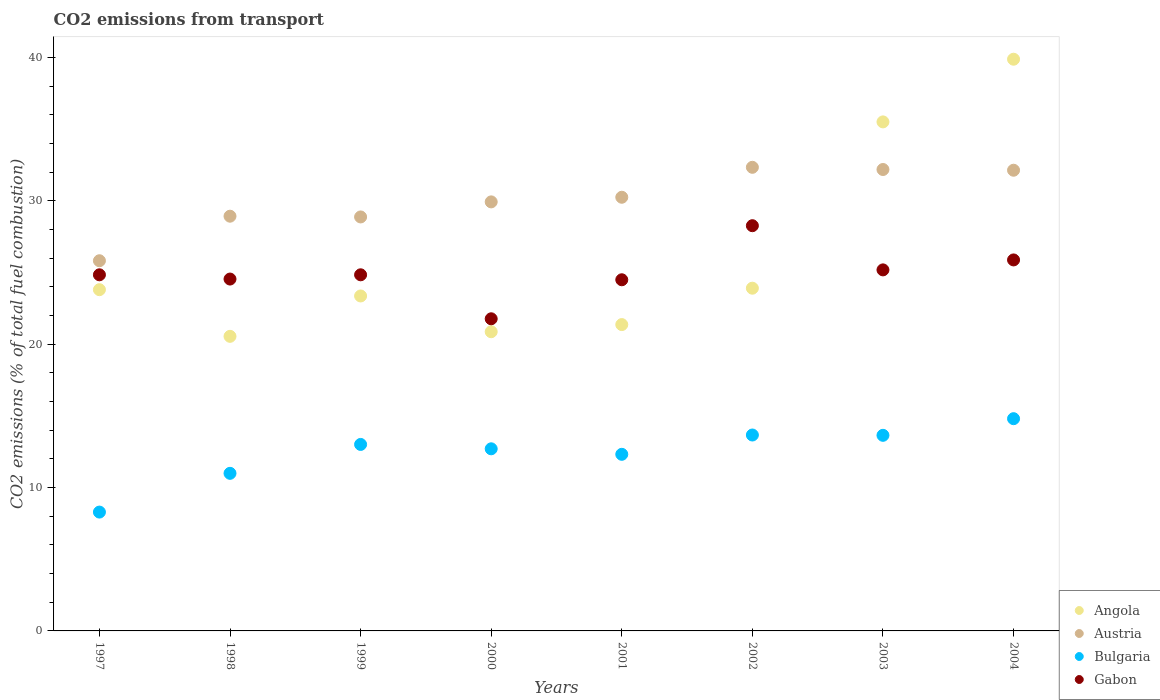Is the number of dotlines equal to the number of legend labels?
Your answer should be very brief. Yes. What is the total CO2 emitted in Gabon in 2002?
Keep it short and to the point. 28.26. Across all years, what is the maximum total CO2 emitted in Gabon?
Offer a terse response. 28.26. Across all years, what is the minimum total CO2 emitted in Gabon?
Your answer should be very brief. 21.77. In which year was the total CO2 emitted in Austria maximum?
Make the answer very short. 2002. What is the total total CO2 emitted in Gabon in the graph?
Offer a very short reply. 199.79. What is the difference between the total CO2 emitted in Bulgaria in 2003 and that in 2004?
Keep it short and to the point. -1.16. What is the difference between the total CO2 emitted in Austria in 2002 and the total CO2 emitted in Bulgaria in 1997?
Give a very brief answer. 24.05. What is the average total CO2 emitted in Bulgaria per year?
Offer a terse response. 12.43. In the year 2001, what is the difference between the total CO2 emitted in Austria and total CO2 emitted in Bulgaria?
Provide a short and direct response. 17.93. In how many years, is the total CO2 emitted in Bulgaria greater than 24?
Keep it short and to the point. 0. What is the ratio of the total CO2 emitted in Austria in 2002 to that in 2003?
Keep it short and to the point. 1. Is the total CO2 emitted in Bulgaria in 1997 less than that in 2000?
Ensure brevity in your answer.  Yes. What is the difference between the highest and the second highest total CO2 emitted in Bulgaria?
Your response must be concise. 1.14. What is the difference between the highest and the lowest total CO2 emitted in Angola?
Provide a short and direct response. 19.33. In how many years, is the total CO2 emitted in Bulgaria greater than the average total CO2 emitted in Bulgaria taken over all years?
Offer a very short reply. 5. Is it the case that in every year, the sum of the total CO2 emitted in Austria and total CO2 emitted in Bulgaria  is greater than the sum of total CO2 emitted in Angola and total CO2 emitted in Gabon?
Provide a short and direct response. Yes. Is the total CO2 emitted in Angola strictly less than the total CO2 emitted in Gabon over the years?
Your response must be concise. No. Are the values on the major ticks of Y-axis written in scientific E-notation?
Offer a terse response. No. Does the graph contain any zero values?
Your answer should be very brief. No. Where does the legend appear in the graph?
Your answer should be very brief. Bottom right. How many legend labels are there?
Keep it short and to the point. 4. How are the legend labels stacked?
Provide a succinct answer. Vertical. What is the title of the graph?
Keep it short and to the point. CO2 emissions from transport. What is the label or title of the X-axis?
Your answer should be very brief. Years. What is the label or title of the Y-axis?
Offer a very short reply. CO2 emissions (% of total fuel combustion). What is the CO2 emissions (% of total fuel combustion) of Angola in 1997?
Make the answer very short. 23.8. What is the CO2 emissions (% of total fuel combustion) in Austria in 1997?
Keep it short and to the point. 25.82. What is the CO2 emissions (% of total fuel combustion) of Bulgaria in 1997?
Give a very brief answer. 8.29. What is the CO2 emissions (% of total fuel combustion) in Gabon in 1997?
Keep it short and to the point. 24.84. What is the CO2 emissions (% of total fuel combustion) of Angola in 1998?
Provide a succinct answer. 20.54. What is the CO2 emissions (% of total fuel combustion) in Austria in 1998?
Offer a terse response. 28.92. What is the CO2 emissions (% of total fuel combustion) of Bulgaria in 1998?
Offer a very short reply. 10.99. What is the CO2 emissions (% of total fuel combustion) in Gabon in 1998?
Offer a terse response. 24.54. What is the CO2 emissions (% of total fuel combustion) in Angola in 1999?
Give a very brief answer. 23.36. What is the CO2 emissions (% of total fuel combustion) in Austria in 1999?
Provide a succinct answer. 28.87. What is the CO2 emissions (% of total fuel combustion) in Bulgaria in 1999?
Your answer should be compact. 13.01. What is the CO2 emissions (% of total fuel combustion) in Gabon in 1999?
Your response must be concise. 24.84. What is the CO2 emissions (% of total fuel combustion) in Angola in 2000?
Keep it short and to the point. 20.87. What is the CO2 emissions (% of total fuel combustion) of Austria in 2000?
Provide a succinct answer. 29.92. What is the CO2 emissions (% of total fuel combustion) of Bulgaria in 2000?
Offer a terse response. 12.7. What is the CO2 emissions (% of total fuel combustion) in Gabon in 2000?
Your answer should be compact. 21.77. What is the CO2 emissions (% of total fuel combustion) in Angola in 2001?
Your answer should be compact. 21.36. What is the CO2 emissions (% of total fuel combustion) of Austria in 2001?
Offer a terse response. 30.24. What is the CO2 emissions (% of total fuel combustion) of Bulgaria in 2001?
Provide a succinct answer. 12.32. What is the CO2 emissions (% of total fuel combustion) in Gabon in 2001?
Offer a terse response. 24.49. What is the CO2 emissions (% of total fuel combustion) of Angola in 2002?
Your response must be concise. 23.9. What is the CO2 emissions (% of total fuel combustion) in Austria in 2002?
Offer a very short reply. 32.33. What is the CO2 emissions (% of total fuel combustion) of Bulgaria in 2002?
Give a very brief answer. 13.66. What is the CO2 emissions (% of total fuel combustion) in Gabon in 2002?
Make the answer very short. 28.26. What is the CO2 emissions (% of total fuel combustion) of Angola in 2003?
Provide a succinct answer. 35.5. What is the CO2 emissions (% of total fuel combustion) of Austria in 2003?
Offer a very short reply. 32.18. What is the CO2 emissions (% of total fuel combustion) in Bulgaria in 2003?
Offer a very short reply. 13.64. What is the CO2 emissions (% of total fuel combustion) in Gabon in 2003?
Offer a very short reply. 25.18. What is the CO2 emissions (% of total fuel combustion) of Angola in 2004?
Keep it short and to the point. 39.87. What is the CO2 emissions (% of total fuel combustion) in Austria in 2004?
Provide a succinct answer. 32.13. What is the CO2 emissions (% of total fuel combustion) in Bulgaria in 2004?
Your answer should be very brief. 14.8. What is the CO2 emissions (% of total fuel combustion) of Gabon in 2004?
Keep it short and to the point. 25.87. Across all years, what is the maximum CO2 emissions (% of total fuel combustion) of Angola?
Keep it short and to the point. 39.87. Across all years, what is the maximum CO2 emissions (% of total fuel combustion) in Austria?
Offer a terse response. 32.33. Across all years, what is the maximum CO2 emissions (% of total fuel combustion) of Bulgaria?
Your answer should be compact. 14.8. Across all years, what is the maximum CO2 emissions (% of total fuel combustion) of Gabon?
Your answer should be very brief. 28.26. Across all years, what is the minimum CO2 emissions (% of total fuel combustion) in Angola?
Offer a terse response. 20.54. Across all years, what is the minimum CO2 emissions (% of total fuel combustion) in Austria?
Your answer should be very brief. 25.82. Across all years, what is the minimum CO2 emissions (% of total fuel combustion) of Bulgaria?
Provide a succinct answer. 8.29. Across all years, what is the minimum CO2 emissions (% of total fuel combustion) of Gabon?
Provide a succinct answer. 21.77. What is the total CO2 emissions (% of total fuel combustion) in Angola in the graph?
Your response must be concise. 209.21. What is the total CO2 emissions (% of total fuel combustion) in Austria in the graph?
Offer a very short reply. 240.42. What is the total CO2 emissions (% of total fuel combustion) of Bulgaria in the graph?
Keep it short and to the point. 99.41. What is the total CO2 emissions (% of total fuel combustion) in Gabon in the graph?
Offer a terse response. 199.79. What is the difference between the CO2 emissions (% of total fuel combustion) of Angola in 1997 and that in 1998?
Your answer should be compact. 3.25. What is the difference between the CO2 emissions (% of total fuel combustion) of Austria in 1997 and that in 1998?
Offer a very short reply. -3.11. What is the difference between the CO2 emissions (% of total fuel combustion) in Bulgaria in 1997 and that in 1998?
Your answer should be very brief. -2.7. What is the difference between the CO2 emissions (% of total fuel combustion) in Gabon in 1997 and that in 1998?
Your response must be concise. 0.3. What is the difference between the CO2 emissions (% of total fuel combustion) of Angola in 1997 and that in 1999?
Offer a terse response. 0.44. What is the difference between the CO2 emissions (% of total fuel combustion) in Austria in 1997 and that in 1999?
Ensure brevity in your answer.  -3.05. What is the difference between the CO2 emissions (% of total fuel combustion) of Bulgaria in 1997 and that in 1999?
Ensure brevity in your answer.  -4.72. What is the difference between the CO2 emissions (% of total fuel combustion) in Angola in 1997 and that in 2000?
Provide a succinct answer. 2.93. What is the difference between the CO2 emissions (% of total fuel combustion) in Austria in 1997 and that in 2000?
Offer a very short reply. -4.1. What is the difference between the CO2 emissions (% of total fuel combustion) in Bulgaria in 1997 and that in 2000?
Offer a terse response. -4.41. What is the difference between the CO2 emissions (% of total fuel combustion) in Gabon in 1997 and that in 2000?
Ensure brevity in your answer.  3.07. What is the difference between the CO2 emissions (% of total fuel combustion) of Angola in 1997 and that in 2001?
Offer a very short reply. 2.43. What is the difference between the CO2 emissions (% of total fuel combustion) of Austria in 1997 and that in 2001?
Your response must be concise. -4.43. What is the difference between the CO2 emissions (% of total fuel combustion) in Bulgaria in 1997 and that in 2001?
Ensure brevity in your answer.  -4.03. What is the difference between the CO2 emissions (% of total fuel combustion) in Gabon in 1997 and that in 2001?
Give a very brief answer. 0.35. What is the difference between the CO2 emissions (% of total fuel combustion) in Angola in 1997 and that in 2002?
Provide a short and direct response. -0.1. What is the difference between the CO2 emissions (% of total fuel combustion) of Austria in 1997 and that in 2002?
Keep it short and to the point. -6.52. What is the difference between the CO2 emissions (% of total fuel combustion) in Bulgaria in 1997 and that in 2002?
Provide a succinct answer. -5.38. What is the difference between the CO2 emissions (% of total fuel combustion) of Gabon in 1997 and that in 2002?
Your answer should be compact. -3.42. What is the difference between the CO2 emissions (% of total fuel combustion) of Angola in 1997 and that in 2003?
Your response must be concise. -11.7. What is the difference between the CO2 emissions (% of total fuel combustion) in Austria in 1997 and that in 2003?
Your answer should be compact. -6.36. What is the difference between the CO2 emissions (% of total fuel combustion) in Bulgaria in 1997 and that in 2003?
Ensure brevity in your answer.  -5.35. What is the difference between the CO2 emissions (% of total fuel combustion) of Gabon in 1997 and that in 2003?
Provide a short and direct response. -0.34. What is the difference between the CO2 emissions (% of total fuel combustion) of Angola in 1997 and that in 2004?
Provide a succinct answer. -16.07. What is the difference between the CO2 emissions (% of total fuel combustion) in Austria in 1997 and that in 2004?
Your answer should be compact. -6.31. What is the difference between the CO2 emissions (% of total fuel combustion) of Bulgaria in 1997 and that in 2004?
Provide a succinct answer. -6.51. What is the difference between the CO2 emissions (% of total fuel combustion) of Gabon in 1997 and that in 2004?
Your answer should be very brief. -1.04. What is the difference between the CO2 emissions (% of total fuel combustion) in Angola in 1998 and that in 1999?
Give a very brief answer. -2.82. What is the difference between the CO2 emissions (% of total fuel combustion) in Austria in 1998 and that in 1999?
Ensure brevity in your answer.  0.05. What is the difference between the CO2 emissions (% of total fuel combustion) of Bulgaria in 1998 and that in 1999?
Provide a short and direct response. -2.02. What is the difference between the CO2 emissions (% of total fuel combustion) in Gabon in 1998 and that in 1999?
Make the answer very short. -0.3. What is the difference between the CO2 emissions (% of total fuel combustion) of Angola in 1998 and that in 2000?
Make the answer very short. -0.32. What is the difference between the CO2 emissions (% of total fuel combustion) in Austria in 1998 and that in 2000?
Your answer should be compact. -1. What is the difference between the CO2 emissions (% of total fuel combustion) in Bulgaria in 1998 and that in 2000?
Make the answer very short. -1.71. What is the difference between the CO2 emissions (% of total fuel combustion) of Gabon in 1998 and that in 2000?
Give a very brief answer. 2.77. What is the difference between the CO2 emissions (% of total fuel combustion) of Angola in 1998 and that in 2001?
Offer a terse response. -0.82. What is the difference between the CO2 emissions (% of total fuel combustion) of Austria in 1998 and that in 2001?
Provide a short and direct response. -1.32. What is the difference between the CO2 emissions (% of total fuel combustion) of Bulgaria in 1998 and that in 2001?
Offer a terse response. -1.33. What is the difference between the CO2 emissions (% of total fuel combustion) in Gabon in 1998 and that in 2001?
Offer a terse response. 0.05. What is the difference between the CO2 emissions (% of total fuel combustion) in Angola in 1998 and that in 2002?
Ensure brevity in your answer.  -3.36. What is the difference between the CO2 emissions (% of total fuel combustion) of Austria in 1998 and that in 2002?
Keep it short and to the point. -3.41. What is the difference between the CO2 emissions (% of total fuel combustion) of Bulgaria in 1998 and that in 2002?
Offer a very short reply. -2.67. What is the difference between the CO2 emissions (% of total fuel combustion) of Gabon in 1998 and that in 2002?
Provide a short and direct response. -3.72. What is the difference between the CO2 emissions (% of total fuel combustion) of Angola in 1998 and that in 2003?
Your answer should be compact. -14.96. What is the difference between the CO2 emissions (% of total fuel combustion) of Austria in 1998 and that in 2003?
Provide a short and direct response. -3.26. What is the difference between the CO2 emissions (% of total fuel combustion) of Bulgaria in 1998 and that in 2003?
Ensure brevity in your answer.  -2.65. What is the difference between the CO2 emissions (% of total fuel combustion) in Gabon in 1998 and that in 2003?
Ensure brevity in your answer.  -0.64. What is the difference between the CO2 emissions (% of total fuel combustion) of Angola in 1998 and that in 2004?
Make the answer very short. -19.33. What is the difference between the CO2 emissions (% of total fuel combustion) of Austria in 1998 and that in 2004?
Give a very brief answer. -3.21. What is the difference between the CO2 emissions (% of total fuel combustion) of Bulgaria in 1998 and that in 2004?
Your answer should be very brief. -3.81. What is the difference between the CO2 emissions (% of total fuel combustion) in Gabon in 1998 and that in 2004?
Keep it short and to the point. -1.33. What is the difference between the CO2 emissions (% of total fuel combustion) of Angola in 1999 and that in 2000?
Your response must be concise. 2.49. What is the difference between the CO2 emissions (% of total fuel combustion) in Austria in 1999 and that in 2000?
Ensure brevity in your answer.  -1.05. What is the difference between the CO2 emissions (% of total fuel combustion) in Bulgaria in 1999 and that in 2000?
Offer a very short reply. 0.31. What is the difference between the CO2 emissions (% of total fuel combustion) in Gabon in 1999 and that in 2000?
Offer a very short reply. 3.07. What is the difference between the CO2 emissions (% of total fuel combustion) of Angola in 1999 and that in 2001?
Keep it short and to the point. 2. What is the difference between the CO2 emissions (% of total fuel combustion) of Austria in 1999 and that in 2001?
Provide a short and direct response. -1.37. What is the difference between the CO2 emissions (% of total fuel combustion) in Bulgaria in 1999 and that in 2001?
Provide a short and direct response. 0.69. What is the difference between the CO2 emissions (% of total fuel combustion) in Gabon in 1999 and that in 2001?
Your answer should be compact. 0.35. What is the difference between the CO2 emissions (% of total fuel combustion) of Angola in 1999 and that in 2002?
Offer a very short reply. -0.54. What is the difference between the CO2 emissions (% of total fuel combustion) in Austria in 1999 and that in 2002?
Offer a very short reply. -3.46. What is the difference between the CO2 emissions (% of total fuel combustion) in Bulgaria in 1999 and that in 2002?
Your answer should be very brief. -0.66. What is the difference between the CO2 emissions (% of total fuel combustion) in Gabon in 1999 and that in 2002?
Your answer should be compact. -3.42. What is the difference between the CO2 emissions (% of total fuel combustion) in Angola in 1999 and that in 2003?
Provide a succinct answer. -12.14. What is the difference between the CO2 emissions (% of total fuel combustion) of Austria in 1999 and that in 2003?
Provide a succinct answer. -3.31. What is the difference between the CO2 emissions (% of total fuel combustion) in Bulgaria in 1999 and that in 2003?
Offer a terse response. -0.64. What is the difference between the CO2 emissions (% of total fuel combustion) of Gabon in 1999 and that in 2003?
Your answer should be very brief. -0.34. What is the difference between the CO2 emissions (% of total fuel combustion) in Angola in 1999 and that in 2004?
Provide a succinct answer. -16.51. What is the difference between the CO2 emissions (% of total fuel combustion) of Austria in 1999 and that in 2004?
Your answer should be very brief. -3.26. What is the difference between the CO2 emissions (% of total fuel combustion) of Bulgaria in 1999 and that in 2004?
Provide a short and direct response. -1.8. What is the difference between the CO2 emissions (% of total fuel combustion) of Gabon in 1999 and that in 2004?
Ensure brevity in your answer.  -1.04. What is the difference between the CO2 emissions (% of total fuel combustion) in Angola in 2000 and that in 2001?
Provide a short and direct response. -0.5. What is the difference between the CO2 emissions (% of total fuel combustion) in Austria in 2000 and that in 2001?
Keep it short and to the point. -0.32. What is the difference between the CO2 emissions (% of total fuel combustion) in Bulgaria in 2000 and that in 2001?
Ensure brevity in your answer.  0.38. What is the difference between the CO2 emissions (% of total fuel combustion) in Gabon in 2000 and that in 2001?
Ensure brevity in your answer.  -2.72. What is the difference between the CO2 emissions (% of total fuel combustion) of Angola in 2000 and that in 2002?
Keep it short and to the point. -3.04. What is the difference between the CO2 emissions (% of total fuel combustion) in Austria in 2000 and that in 2002?
Offer a very short reply. -2.41. What is the difference between the CO2 emissions (% of total fuel combustion) in Bulgaria in 2000 and that in 2002?
Provide a succinct answer. -0.96. What is the difference between the CO2 emissions (% of total fuel combustion) in Gabon in 2000 and that in 2002?
Your answer should be compact. -6.49. What is the difference between the CO2 emissions (% of total fuel combustion) of Angola in 2000 and that in 2003?
Your answer should be compact. -14.63. What is the difference between the CO2 emissions (% of total fuel combustion) of Austria in 2000 and that in 2003?
Your response must be concise. -2.26. What is the difference between the CO2 emissions (% of total fuel combustion) of Bulgaria in 2000 and that in 2003?
Keep it short and to the point. -0.94. What is the difference between the CO2 emissions (% of total fuel combustion) of Gabon in 2000 and that in 2003?
Give a very brief answer. -3.41. What is the difference between the CO2 emissions (% of total fuel combustion) in Angola in 2000 and that in 2004?
Your response must be concise. -19.01. What is the difference between the CO2 emissions (% of total fuel combustion) in Austria in 2000 and that in 2004?
Your answer should be very brief. -2.21. What is the difference between the CO2 emissions (% of total fuel combustion) of Bulgaria in 2000 and that in 2004?
Offer a very short reply. -2.1. What is the difference between the CO2 emissions (% of total fuel combustion) in Gabon in 2000 and that in 2004?
Give a very brief answer. -4.11. What is the difference between the CO2 emissions (% of total fuel combustion) of Angola in 2001 and that in 2002?
Offer a terse response. -2.54. What is the difference between the CO2 emissions (% of total fuel combustion) of Austria in 2001 and that in 2002?
Provide a short and direct response. -2.09. What is the difference between the CO2 emissions (% of total fuel combustion) of Bulgaria in 2001 and that in 2002?
Provide a short and direct response. -1.35. What is the difference between the CO2 emissions (% of total fuel combustion) in Gabon in 2001 and that in 2002?
Your answer should be very brief. -3.77. What is the difference between the CO2 emissions (% of total fuel combustion) of Angola in 2001 and that in 2003?
Your answer should be very brief. -14.14. What is the difference between the CO2 emissions (% of total fuel combustion) in Austria in 2001 and that in 2003?
Your answer should be compact. -1.94. What is the difference between the CO2 emissions (% of total fuel combustion) in Bulgaria in 2001 and that in 2003?
Ensure brevity in your answer.  -1.32. What is the difference between the CO2 emissions (% of total fuel combustion) in Gabon in 2001 and that in 2003?
Your answer should be compact. -0.69. What is the difference between the CO2 emissions (% of total fuel combustion) of Angola in 2001 and that in 2004?
Keep it short and to the point. -18.51. What is the difference between the CO2 emissions (% of total fuel combustion) in Austria in 2001 and that in 2004?
Ensure brevity in your answer.  -1.89. What is the difference between the CO2 emissions (% of total fuel combustion) in Bulgaria in 2001 and that in 2004?
Your answer should be very brief. -2.48. What is the difference between the CO2 emissions (% of total fuel combustion) of Gabon in 2001 and that in 2004?
Your answer should be very brief. -1.38. What is the difference between the CO2 emissions (% of total fuel combustion) in Angola in 2002 and that in 2003?
Your answer should be very brief. -11.6. What is the difference between the CO2 emissions (% of total fuel combustion) of Austria in 2002 and that in 2003?
Provide a short and direct response. 0.15. What is the difference between the CO2 emissions (% of total fuel combustion) in Bulgaria in 2002 and that in 2003?
Give a very brief answer. 0.02. What is the difference between the CO2 emissions (% of total fuel combustion) of Gabon in 2002 and that in 2003?
Give a very brief answer. 3.08. What is the difference between the CO2 emissions (% of total fuel combustion) in Angola in 2002 and that in 2004?
Offer a terse response. -15.97. What is the difference between the CO2 emissions (% of total fuel combustion) in Austria in 2002 and that in 2004?
Provide a succinct answer. 0.2. What is the difference between the CO2 emissions (% of total fuel combustion) of Bulgaria in 2002 and that in 2004?
Provide a succinct answer. -1.14. What is the difference between the CO2 emissions (% of total fuel combustion) of Gabon in 2002 and that in 2004?
Ensure brevity in your answer.  2.39. What is the difference between the CO2 emissions (% of total fuel combustion) of Angola in 2003 and that in 2004?
Give a very brief answer. -4.37. What is the difference between the CO2 emissions (% of total fuel combustion) in Austria in 2003 and that in 2004?
Your answer should be very brief. 0.05. What is the difference between the CO2 emissions (% of total fuel combustion) in Bulgaria in 2003 and that in 2004?
Give a very brief answer. -1.16. What is the difference between the CO2 emissions (% of total fuel combustion) of Gabon in 2003 and that in 2004?
Provide a short and direct response. -0.69. What is the difference between the CO2 emissions (% of total fuel combustion) of Angola in 1997 and the CO2 emissions (% of total fuel combustion) of Austria in 1998?
Give a very brief answer. -5.12. What is the difference between the CO2 emissions (% of total fuel combustion) of Angola in 1997 and the CO2 emissions (% of total fuel combustion) of Bulgaria in 1998?
Your answer should be very brief. 12.81. What is the difference between the CO2 emissions (% of total fuel combustion) in Angola in 1997 and the CO2 emissions (% of total fuel combustion) in Gabon in 1998?
Your answer should be compact. -0.74. What is the difference between the CO2 emissions (% of total fuel combustion) of Austria in 1997 and the CO2 emissions (% of total fuel combustion) of Bulgaria in 1998?
Provide a succinct answer. 14.83. What is the difference between the CO2 emissions (% of total fuel combustion) in Austria in 1997 and the CO2 emissions (% of total fuel combustion) in Gabon in 1998?
Provide a succinct answer. 1.28. What is the difference between the CO2 emissions (% of total fuel combustion) of Bulgaria in 1997 and the CO2 emissions (% of total fuel combustion) of Gabon in 1998?
Keep it short and to the point. -16.25. What is the difference between the CO2 emissions (% of total fuel combustion) in Angola in 1997 and the CO2 emissions (% of total fuel combustion) in Austria in 1999?
Your answer should be very brief. -5.07. What is the difference between the CO2 emissions (% of total fuel combustion) of Angola in 1997 and the CO2 emissions (% of total fuel combustion) of Bulgaria in 1999?
Make the answer very short. 10.79. What is the difference between the CO2 emissions (% of total fuel combustion) in Angola in 1997 and the CO2 emissions (% of total fuel combustion) in Gabon in 1999?
Your answer should be very brief. -1.04. What is the difference between the CO2 emissions (% of total fuel combustion) of Austria in 1997 and the CO2 emissions (% of total fuel combustion) of Bulgaria in 1999?
Give a very brief answer. 12.81. What is the difference between the CO2 emissions (% of total fuel combustion) of Austria in 1997 and the CO2 emissions (% of total fuel combustion) of Gabon in 1999?
Your response must be concise. 0.98. What is the difference between the CO2 emissions (% of total fuel combustion) in Bulgaria in 1997 and the CO2 emissions (% of total fuel combustion) in Gabon in 1999?
Your response must be concise. -16.55. What is the difference between the CO2 emissions (% of total fuel combustion) of Angola in 1997 and the CO2 emissions (% of total fuel combustion) of Austria in 2000?
Your answer should be compact. -6.12. What is the difference between the CO2 emissions (% of total fuel combustion) in Angola in 1997 and the CO2 emissions (% of total fuel combustion) in Bulgaria in 2000?
Provide a succinct answer. 11.1. What is the difference between the CO2 emissions (% of total fuel combustion) of Angola in 1997 and the CO2 emissions (% of total fuel combustion) of Gabon in 2000?
Provide a succinct answer. 2.03. What is the difference between the CO2 emissions (% of total fuel combustion) of Austria in 1997 and the CO2 emissions (% of total fuel combustion) of Bulgaria in 2000?
Give a very brief answer. 13.12. What is the difference between the CO2 emissions (% of total fuel combustion) of Austria in 1997 and the CO2 emissions (% of total fuel combustion) of Gabon in 2000?
Provide a succinct answer. 4.05. What is the difference between the CO2 emissions (% of total fuel combustion) of Bulgaria in 1997 and the CO2 emissions (% of total fuel combustion) of Gabon in 2000?
Your response must be concise. -13.48. What is the difference between the CO2 emissions (% of total fuel combustion) in Angola in 1997 and the CO2 emissions (% of total fuel combustion) in Austria in 2001?
Provide a succinct answer. -6.45. What is the difference between the CO2 emissions (% of total fuel combustion) of Angola in 1997 and the CO2 emissions (% of total fuel combustion) of Bulgaria in 2001?
Make the answer very short. 11.48. What is the difference between the CO2 emissions (% of total fuel combustion) in Angola in 1997 and the CO2 emissions (% of total fuel combustion) in Gabon in 2001?
Keep it short and to the point. -0.69. What is the difference between the CO2 emissions (% of total fuel combustion) in Austria in 1997 and the CO2 emissions (% of total fuel combustion) in Bulgaria in 2001?
Offer a terse response. 13.5. What is the difference between the CO2 emissions (% of total fuel combustion) of Austria in 1997 and the CO2 emissions (% of total fuel combustion) of Gabon in 2001?
Provide a short and direct response. 1.33. What is the difference between the CO2 emissions (% of total fuel combustion) of Bulgaria in 1997 and the CO2 emissions (% of total fuel combustion) of Gabon in 2001?
Provide a succinct answer. -16.2. What is the difference between the CO2 emissions (% of total fuel combustion) in Angola in 1997 and the CO2 emissions (% of total fuel combustion) in Austria in 2002?
Your answer should be compact. -8.54. What is the difference between the CO2 emissions (% of total fuel combustion) of Angola in 1997 and the CO2 emissions (% of total fuel combustion) of Bulgaria in 2002?
Give a very brief answer. 10.14. What is the difference between the CO2 emissions (% of total fuel combustion) in Angola in 1997 and the CO2 emissions (% of total fuel combustion) in Gabon in 2002?
Keep it short and to the point. -4.46. What is the difference between the CO2 emissions (% of total fuel combustion) of Austria in 1997 and the CO2 emissions (% of total fuel combustion) of Bulgaria in 2002?
Provide a short and direct response. 12.15. What is the difference between the CO2 emissions (% of total fuel combustion) of Austria in 1997 and the CO2 emissions (% of total fuel combustion) of Gabon in 2002?
Give a very brief answer. -2.44. What is the difference between the CO2 emissions (% of total fuel combustion) in Bulgaria in 1997 and the CO2 emissions (% of total fuel combustion) in Gabon in 2002?
Ensure brevity in your answer.  -19.97. What is the difference between the CO2 emissions (% of total fuel combustion) in Angola in 1997 and the CO2 emissions (% of total fuel combustion) in Austria in 2003?
Provide a succinct answer. -8.38. What is the difference between the CO2 emissions (% of total fuel combustion) of Angola in 1997 and the CO2 emissions (% of total fuel combustion) of Bulgaria in 2003?
Your response must be concise. 10.16. What is the difference between the CO2 emissions (% of total fuel combustion) of Angola in 1997 and the CO2 emissions (% of total fuel combustion) of Gabon in 2003?
Offer a very short reply. -1.38. What is the difference between the CO2 emissions (% of total fuel combustion) of Austria in 1997 and the CO2 emissions (% of total fuel combustion) of Bulgaria in 2003?
Provide a short and direct response. 12.18. What is the difference between the CO2 emissions (% of total fuel combustion) of Austria in 1997 and the CO2 emissions (% of total fuel combustion) of Gabon in 2003?
Your response must be concise. 0.64. What is the difference between the CO2 emissions (% of total fuel combustion) in Bulgaria in 1997 and the CO2 emissions (% of total fuel combustion) in Gabon in 2003?
Provide a succinct answer. -16.89. What is the difference between the CO2 emissions (% of total fuel combustion) of Angola in 1997 and the CO2 emissions (% of total fuel combustion) of Austria in 2004?
Your response must be concise. -8.33. What is the difference between the CO2 emissions (% of total fuel combustion) of Angola in 1997 and the CO2 emissions (% of total fuel combustion) of Bulgaria in 2004?
Give a very brief answer. 9. What is the difference between the CO2 emissions (% of total fuel combustion) of Angola in 1997 and the CO2 emissions (% of total fuel combustion) of Gabon in 2004?
Your answer should be compact. -2.08. What is the difference between the CO2 emissions (% of total fuel combustion) of Austria in 1997 and the CO2 emissions (% of total fuel combustion) of Bulgaria in 2004?
Keep it short and to the point. 11.02. What is the difference between the CO2 emissions (% of total fuel combustion) of Austria in 1997 and the CO2 emissions (% of total fuel combustion) of Gabon in 2004?
Your answer should be very brief. -0.06. What is the difference between the CO2 emissions (% of total fuel combustion) of Bulgaria in 1997 and the CO2 emissions (% of total fuel combustion) of Gabon in 2004?
Give a very brief answer. -17.59. What is the difference between the CO2 emissions (% of total fuel combustion) of Angola in 1998 and the CO2 emissions (% of total fuel combustion) of Austria in 1999?
Ensure brevity in your answer.  -8.33. What is the difference between the CO2 emissions (% of total fuel combustion) in Angola in 1998 and the CO2 emissions (% of total fuel combustion) in Bulgaria in 1999?
Give a very brief answer. 7.54. What is the difference between the CO2 emissions (% of total fuel combustion) in Angola in 1998 and the CO2 emissions (% of total fuel combustion) in Gabon in 1999?
Provide a short and direct response. -4.29. What is the difference between the CO2 emissions (% of total fuel combustion) of Austria in 1998 and the CO2 emissions (% of total fuel combustion) of Bulgaria in 1999?
Make the answer very short. 15.92. What is the difference between the CO2 emissions (% of total fuel combustion) in Austria in 1998 and the CO2 emissions (% of total fuel combustion) in Gabon in 1999?
Provide a short and direct response. 4.09. What is the difference between the CO2 emissions (% of total fuel combustion) of Bulgaria in 1998 and the CO2 emissions (% of total fuel combustion) of Gabon in 1999?
Offer a very short reply. -13.85. What is the difference between the CO2 emissions (% of total fuel combustion) in Angola in 1998 and the CO2 emissions (% of total fuel combustion) in Austria in 2000?
Make the answer very short. -9.38. What is the difference between the CO2 emissions (% of total fuel combustion) in Angola in 1998 and the CO2 emissions (% of total fuel combustion) in Bulgaria in 2000?
Keep it short and to the point. 7.84. What is the difference between the CO2 emissions (% of total fuel combustion) of Angola in 1998 and the CO2 emissions (% of total fuel combustion) of Gabon in 2000?
Offer a terse response. -1.22. What is the difference between the CO2 emissions (% of total fuel combustion) of Austria in 1998 and the CO2 emissions (% of total fuel combustion) of Bulgaria in 2000?
Give a very brief answer. 16.22. What is the difference between the CO2 emissions (% of total fuel combustion) in Austria in 1998 and the CO2 emissions (% of total fuel combustion) in Gabon in 2000?
Offer a terse response. 7.15. What is the difference between the CO2 emissions (% of total fuel combustion) in Bulgaria in 1998 and the CO2 emissions (% of total fuel combustion) in Gabon in 2000?
Offer a terse response. -10.78. What is the difference between the CO2 emissions (% of total fuel combustion) in Angola in 1998 and the CO2 emissions (% of total fuel combustion) in Bulgaria in 2001?
Keep it short and to the point. 8.23. What is the difference between the CO2 emissions (% of total fuel combustion) of Angola in 1998 and the CO2 emissions (% of total fuel combustion) of Gabon in 2001?
Offer a terse response. -3.95. What is the difference between the CO2 emissions (% of total fuel combustion) of Austria in 1998 and the CO2 emissions (% of total fuel combustion) of Bulgaria in 2001?
Give a very brief answer. 16.61. What is the difference between the CO2 emissions (% of total fuel combustion) in Austria in 1998 and the CO2 emissions (% of total fuel combustion) in Gabon in 2001?
Offer a terse response. 4.43. What is the difference between the CO2 emissions (% of total fuel combustion) in Bulgaria in 1998 and the CO2 emissions (% of total fuel combustion) in Gabon in 2001?
Give a very brief answer. -13.5. What is the difference between the CO2 emissions (% of total fuel combustion) in Angola in 1998 and the CO2 emissions (% of total fuel combustion) in Austria in 2002?
Make the answer very short. -11.79. What is the difference between the CO2 emissions (% of total fuel combustion) in Angola in 1998 and the CO2 emissions (% of total fuel combustion) in Bulgaria in 2002?
Give a very brief answer. 6.88. What is the difference between the CO2 emissions (% of total fuel combustion) in Angola in 1998 and the CO2 emissions (% of total fuel combustion) in Gabon in 2002?
Your answer should be compact. -7.72. What is the difference between the CO2 emissions (% of total fuel combustion) in Austria in 1998 and the CO2 emissions (% of total fuel combustion) in Bulgaria in 2002?
Keep it short and to the point. 15.26. What is the difference between the CO2 emissions (% of total fuel combustion) in Austria in 1998 and the CO2 emissions (% of total fuel combustion) in Gabon in 2002?
Provide a short and direct response. 0.66. What is the difference between the CO2 emissions (% of total fuel combustion) of Bulgaria in 1998 and the CO2 emissions (% of total fuel combustion) of Gabon in 2002?
Your response must be concise. -17.27. What is the difference between the CO2 emissions (% of total fuel combustion) in Angola in 1998 and the CO2 emissions (% of total fuel combustion) in Austria in 2003?
Your answer should be very brief. -11.64. What is the difference between the CO2 emissions (% of total fuel combustion) of Angola in 1998 and the CO2 emissions (% of total fuel combustion) of Bulgaria in 2003?
Provide a succinct answer. 6.9. What is the difference between the CO2 emissions (% of total fuel combustion) of Angola in 1998 and the CO2 emissions (% of total fuel combustion) of Gabon in 2003?
Provide a short and direct response. -4.64. What is the difference between the CO2 emissions (% of total fuel combustion) in Austria in 1998 and the CO2 emissions (% of total fuel combustion) in Bulgaria in 2003?
Provide a short and direct response. 15.28. What is the difference between the CO2 emissions (% of total fuel combustion) in Austria in 1998 and the CO2 emissions (% of total fuel combustion) in Gabon in 2003?
Make the answer very short. 3.74. What is the difference between the CO2 emissions (% of total fuel combustion) of Bulgaria in 1998 and the CO2 emissions (% of total fuel combustion) of Gabon in 2003?
Your answer should be compact. -14.19. What is the difference between the CO2 emissions (% of total fuel combustion) in Angola in 1998 and the CO2 emissions (% of total fuel combustion) in Austria in 2004?
Your answer should be compact. -11.59. What is the difference between the CO2 emissions (% of total fuel combustion) in Angola in 1998 and the CO2 emissions (% of total fuel combustion) in Bulgaria in 2004?
Provide a succinct answer. 5.74. What is the difference between the CO2 emissions (% of total fuel combustion) of Angola in 1998 and the CO2 emissions (% of total fuel combustion) of Gabon in 2004?
Keep it short and to the point. -5.33. What is the difference between the CO2 emissions (% of total fuel combustion) of Austria in 1998 and the CO2 emissions (% of total fuel combustion) of Bulgaria in 2004?
Your answer should be compact. 14.12. What is the difference between the CO2 emissions (% of total fuel combustion) of Austria in 1998 and the CO2 emissions (% of total fuel combustion) of Gabon in 2004?
Your answer should be very brief. 3.05. What is the difference between the CO2 emissions (% of total fuel combustion) in Bulgaria in 1998 and the CO2 emissions (% of total fuel combustion) in Gabon in 2004?
Make the answer very short. -14.88. What is the difference between the CO2 emissions (% of total fuel combustion) in Angola in 1999 and the CO2 emissions (% of total fuel combustion) in Austria in 2000?
Your answer should be compact. -6.56. What is the difference between the CO2 emissions (% of total fuel combustion) of Angola in 1999 and the CO2 emissions (% of total fuel combustion) of Bulgaria in 2000?
Your response must be concise. 10.66. What is the difference between the CO2 emissions (% of total fuel combustion) of Angola in 1999 and the CO2 emissions (% of total fuel combustion) of Gabon in 2000?
Ensure brevity in your answer.  1.59. What is the difference between the CO2 emissions (% of total fuel combustion) of Austria in 1999 and the CO2 emissions (% of total fuel combustion) of Bulgaria in 2000?
Make the answer very short. 16.17. What is the difference between the CO2 emissions (% of total fuel combustion) of Austria in 1999 and the CO2 emissions (% of total fuel combustion) of Gabon in 2000?
Your answer should be very brief. 7.1. What is the difference between the CO2 emissions (% of total fuel combustion) of Bulgaria in 1999 and the CO2 emissions (% of total fuel combustion) of Gabon in 2000?
Provide a short and direct response. -8.76. What is the difference between the CO2 emissions (% of total fuel combustion) in Angola in 1999 and the CO2 emissions (% of total fuel combustion) in Austria in 2001?
Your response must be concise. -6.88. What is the difference between the CO2 emissions (% of total fuel combustion) in Angola in 1999 and the CO2 emissions (% of total fuel combustion) in Bulgaria in 2001?
Ensure brevity in your answer.  11.04. What is the difference between the CO2 emissions (% of total fuel combustion) of Angola in 1999 and the CO2 emissions (% of total fuel combustion) of Gabon in 2001?
Your answer should be compact. -1.13. What is the difference between the CO2 emissions (% of total fuel combustion) of Austria in 1999 and the CO2 emissions (% of total fuel combustion) of Bulgaria in 2001?
Keep it short and to the point. 16.55. What is the difference between the CO2 emissions (% of total fuel combustion) of Austria in 1999 and the CO2 emissions (% of total fuel combustion) of Gabon in 2001?
Offer a terse response. 4.38. What is the difference between the CO2 emissions (% of total fuel combustion) of Bulgaria in 1999 and the CO2 emissions (% of total fuel combustion) of Gabon in 2001?
Keep it short and to the point. -11.48. What is the difference between the CO2 emissions (% of total fuel combustion) in Angola in 1999 and the CO2 emissions (% of total fuel combustion) in Austria in 2002?
Offer a very short reply. -8.97. What is the difference between the CO2 emissions (% of total fuel combustion) of Angola in 1999 and the CO2 emissions (% of total fuel combustion) of Bulgaria in 2002?
Your answer should be very brief. 9.7. What is the difference between the CO2 emissions (% of total fuel combustion) of Angola in 1999 and the CO2 emissions (% of total fuel combustion) of Gabon in 2002?
Provide a short and direct response. -4.9. What is the difference between the CO2 emissions (% of total fuel combustion) of Austria in 1999 and the CO2 emissions (% of total fuel combustion) of Bulgaria in 2002?
Your answer should be compact. 15.21. What is the difference between the CO2 emissions (% of total fuel combustion) in Austria in 1999 and the CO2 emissions (% of total fuel combustion) in Gabon in 2002?
Make the answer very short. 0.61. What is the difference between the CO2 emissions (% of total fuel combustion) in Bulgaria in 1999 and the CO2 emissions (% of total fuel combustion) in Gabon in 2002?
Provide a succinct answer. -15.25. What is the difference between the CO2 emissions (% of total fuel combustion) in Angola in 1999 and the CO2 emissions (% of total fuel combustion) in Austria in 2003?
Your answer should be very brief. -8.82. What is the difference between the CO2 emissions (% of total fuel combustion) of Angola in 1999 and the CO2 emissions (% of total fuel combustion) of Bulgaria in 2003?
Offer a terse response. 9.72. What is the difference between the CO2 emissions (% of total fuel combustion) in Angola in 1999 and the CO2 emissions (% of total fuel combustion) in Gabon in 2003?
Provide a short and direct response. -1.82. What is the difference between the CO2 emissions (% of total fuel combustion) of Austria in 1999 and the CO2 emissions (% of total fuel combustion) of Bulgaria in 2003?
Your response must be concise. 15.23. What is the difference between the CO2 emissions (% of total fuel combustion) of Austria in 1999 and the CO2 emissions (% of total fuel combustion) of Gabon in 2003?
Provide a succinct answer. 3.69. What is the difference between the CO2 emissions (% of total fuel combustion) of Bulgaria in 1999 and the CO2 emissions (% of total fuel combustion) of Gabon in 2003?
Make the answer very short. -12.17. What is the difference between the CO2 emissions (% of total fuel combustion) in Angola in 1999 and the CO2 emissions (% of total fuel combustion) in Austria in 2004?
Keep it short and to the point. -8.77. What is the difference between the CO2 emissions (% of total fuel combustion) of Angola in 1999 and the CO2 emissions (% of total fuel combustion) of Bulgaria in 2004?
Offer a terse response. 8.56. What is the difference between the CO2 emissions (% of total fuel combustion) of Angola in 1999 and the CO2 emissions (% of total fuel combustion) of Gabon in 2004?
Your answer should be compact. -2.51. What is the difference between the CO2 emissions (% of total fuel combustion) in Austria in 1999 and the CO2 emissions (% of total fuel combustion) in Bulgaria in 2004?
Keep it short and to the point. 14.07. What is the difference between the CO2 emissions (% of total fuel combustion) in Austria in 1999 and the CO2 emissions (% of total fuel combustion) in Gabon in 2004?
Ensure brevity in your answer.  3. What is the difference between the CO2 emissions (% of total fuel combustion) of Bulgaria in 1999 and the CO2 emissions (% of total fuel combustion) of Gabon in 2004?
Make the answer very short. -12.87. What is the difference between the CO2 emissions (% of total fuel combustion) of Angola in 2000 and the CO2 emissions (% of total fuel combustion) of Austria in 2001?
Your response must be concise. -9.38. What is the difference between the CO2 emissions (% of total fuel combustion) of Angola in 2000 and the CO2 emissions (% of total fuel combustion) of Bulgaria in 2001?
Offer a terse response. 8.55. What is the difference between the CO2 emissions (% of total fuel combustion) of Angola in 2000 and the CO2 emissions (% of total fuel combustion) of Gabon in 2001?
Give a very brief answer. -3.62. What is the difference between the CO2 emissions (% of total fuel combustion) of Austria in 2000 and the CO2 emissions (% of total fuel combustion) of Bulgaria in 2001?
Offer a very short reply. 17.61. What is the difference between the CO2 emissions (% of total fuel combustion) in Austria in 2000 and the CO2 emissions (% of total fuel combustion) in Gabon in 2001?
Ensure brevity in your answer.  5.43. What is the difference between the CO2 emissions (% of total fuel combustion) of Bulgaria in 2000 and the CO2 emissions (% of total fuel combustion) of Gabon in 2001?
Keep it short and to the point. -11.79. What is the difference between the CO2 emissions (% of total fuel combustion) in Angola in 2000 and the CO2 emissions (% of total fuel combustion) in Austria in 2002?
Ensure brevity in your answer.  -11.47. What is the difference between the CO2 emissions (% of total fuel combustion) in Angola in 2000 and the CO2 emissions (% of total fuel combustion) in Bulgaria in 2002?
Offer a very short reply. 7.2. What is the difference between the CO2 emissions (% of total fuel combustion) in Angola in 2000 and the CO2 emissions (% of total fuel combustion) in Gabon in 2002?
Your answer should be compact. -7.39. What is the difference between the CO2 emissions (% of total fuel combustion) in Austria in 2000 and the CO2 emissions (% of total fuel combustion) in Bulgaria in 2002?
Your answer should be very brief. 16.26. What is the difference between the CO2 emissions (% of total fuel combustion) in Austria in 2000 and the CO2 emissions (% of total fuel combustion) in Gabon in 2002?
Offer a very short reply. 1.66. What is the difference between the CO2 emissions (% of total fuel combustion) in Bulgaria in 2000 and the CO2 emissions (% of total fuel combustion) in Gabon in 2002?
Provide a succinct answer. -15.56. What is the difference between the CO2 emissions (% of total fuel combustion) in Angola in 2000 and the CO2 emissions (% of total fuel combustion) in Austria in 2003?
Make the answer very short. -11.31. What is the difference between the CO2 emissions (% of total fuel combustion) in Angola in 2000 and the CO2 emissions (% of total fuel combustion) in Bulgaria in 2003?
Provide a succinct answer. 7.22. What is the difference between the CO2 emissions (% of total fuel combustion) of Angola in 2000 and the CO2 emissions (% of total fuel combustion) of Gabon in 2003?
Offer a very short reply. -4.31. What is the difference between the CO2 emissions (% of total fuel combustion) of Austria in 2000 and the CO2 emissions (% of total fuel combustion) of Bulgaria in 2003?
Make the answer very short. 16.28. What is the difference between the CO2 emissions (% of total fuel combustion) in Austria in 2000 and the CO2 emissions (% of total fuel combustion) in Gabon in 2003?
Provide a short and direct response. 4.74. What is the difference between the CO2 emissions (% of total fuel combustion) in Bulgaria in 2000 and the CO2 emissions (% of total fuel combustion) in Gabon in 2003?
Your response must be concise. -12.48. What is the difference between the CO2 emissions (% of total fuel combustion) of Angola in 2000 and the CO2 emissions (% of total fuel combustion) of Austria in 2004?
Provide a short and direct response. -11.26. What is the difference between the CO2 emissions (% of total fuel combustion) of Angola in 2000 and the CO2 emissions (% of total fuel combustion) of Bulgaria in 2004?
Provide a short and direct response. 6.06. What is the difference between the CO2 emissions (% of total fuel combustion) of Angola in 2000 and the CO2 emissions (% of total fuel combustion) of Gabon in 2004?
Provide a short and direct response. -5.01. What is the difference between the CO2 emissions (% of total fuel combustion) in Austria in 2000 and the CO2 emissions (% of total fuel combustion) in Bulgaria in 2004?
Make the answer very short. 15.12. What is the difference between the CO2 emissions (% of total fuel combustion) of Austria in 2000 and the CO2 emissions (% of total fuel combustion) of Gabon in 2004?
Ensure brevity in your answer.  4.05. What is the difference between the CO2 emissions (% of total fuel combustion) in Bulgaria in 2000 and the CO2 emissions (% of total fuel combustion) in Gabon in 2004?
Offer a very short reply. -13.17. What is the difference between the CO2 emissions (% of total fuel combustion) of Angola in 2001 and the CO2 emissions (% of total fuel combustion) of Austria in 2002?
Your response must be concise. -10.97. What is the difference between the CO2 emissions (% of total fuel combustion) of Angola in 2001 and the CO2 emissions (% of total fuel combustion) of Bulgaria in 2002?
Keep it short and to the point. 7.7. What is the difference between the CO2 emissions (% of total fuel combustion) of Angola in 2001 and the CO2 emissions (% of total fuel combustion) of Gabon in 2002?
Your answer should be very brief. -6.9. What is the difference between the CO2 emissions (% of total fuel combustion) of Austria in 2001 and the CO2 emissions (% of total fuel combustion) of Bulgaria in 2002?
Offer a very short reply. 16.58. What is the difference between the CO2 emissions (% of total fuel combustion) of Austria in 2001 and the CO2 emissions (% of total fuel combustion) of Gabon in 2002?
Provide a succinct answer. 1.98. What is the difference between the CO2 emissions (% of total fuel combustion) in Bulgaria in 2001 and the CO2 emissions (% of total fuel combustion) in Gabon in 2002?
Your answer should be compact. -15.94. What is the difference between the CO2 emissions (% of total fuel combustion) in Angola in 2001 and the CO2 emissions (% of total fuel combustion) in Austria in 2003?
Give a very brief answer. -10.82. What is the difference between the CO2 emissions (% of total fuel combustion) of Angola in 2001 and the CO2 emissions (% of total fuel combustion) of Bulgaria in 2003?
Ensure brevity in your answer.  7.72. What is the difference between the CO2 emissions (% of total fuel combustion) in Angola in 2001 and the CO2 emissions (% of total fuel combustion) in Gabon in 2003?
Provide a short and direct response. -3.82. What is the difference between the CO2 emissions (% of total fuel combustion) in Austria in 2001 and the CO2 emissions (% of total fuel combustion) in Bulgaria in 2003?
Make the answer very short. 16.6. What is the difference between the CO2 emissions (% of total fuel combustion) of Austria in 2001 and the CO2 emissions (% of total fuel combustion) of Gabon in 2003?
Ensure brevity in your answer.  5.06. What is the difference between the CO2 emissions (% of total fuel combustion) in Bulgaria in 2001 and the CO2 emissions (% of total fuel combustion) in Gabon in 2003?
Your response must be concise. -12.86. What is the difference between the CO2 emissions (% of total fuel combustion) of Angola in 2001 and the CO2 emissions (% of total fuel combustion) of Austria in 2004?
Provide a succinct answer. -10.77. What is the difference between the CO2 emissions (% of total fuel combustion) of Angola in 2001 and the CO2 emissions (% of total fuel combustion) of Bulgaria in 2004?
Make the answer very short. 6.56. What is the difference between the CO2 emissions (% of total fuel combustion) in Angola in 2001 and the CO2 emissions (% of total fuel combustion) in Gabon in 2004?
Keep it short and to the point. -4.51. What is the difference between the CO2 emissions (% of total fuel combustion) of Austria in 2001 and the CO2 emissions (% of total fuel combustion) of Bulgaria in 2004?
Your response must be concise. 15.44. What is the difference between the CO2 emissions (% of total fuel combustion) of Austria in 2001 and the CO2 emissions (% of total fuel combustion) of Gabon in 2004?
Make the answer very short. 4.37. What is the difference between the CO2 emissions (% of total fuel combustion) in Bulgaria in 2001 and the CO2 emissions (% of total fuel combustion) in Gabon in 2004?
Offer a terse response. -13.56. What is the difference between the CO2 emissions (% of total fuel combustion) of Angola in 2002 and the CO2 emissions (% of total fuel combustion) of Austria in 2003?
Provide a succinct answer. -8.28. What is the difference between the CO2 emissions (% of total fuel combustion) of Angola in 2002 and the CO2 emissions (% of total fuel combustion) of Bulgaria in 2003?
Your answer should be compact. 10.26. What is the difference between the CO2 emissions (% of total fuel combustion) in Angola in 2002 and the CO2 emissions (% of total fuel combustion) in Gabon in 2003?
Your answer should be compact. -1.28. What is the difference between the CO2 emissions (% of total fuel combustion) of Austria in 2002 and the CO2 emissions (% of total fuel combustion) of Bulgaria in 2003?
Offer a very short reply. 18.69. What is the difference between the CO2 emissions (% of total fuel combustion) in Austria in 2002 and the CO2 emissions (% of total fuel combustion) in Gabon in 2003?
Ensure brevity in your answer.  7.15. What is the difference between the CO2 emissions (% of total fuel combustion) in Bulgaria in 2002 and the CO2 emissions (% of total fuel combustion) in Gabon in 2003?
Provide a succinct answer. -11.52. What is the difference between the CO2 emissions (% of total fuel combustion) in Angola in 2002 and the CO2 emissions (% of total fuel combustion) in Austria in 2004?
Give a very brief answer. -8.23. What is the difference between the CO2 emissions (% of total fuel combustion) of Angola in 2002 and the CO2 emissions (% of total fuel combustion) of Bulgaria in 2004?
Offer a terse response. 9.1. What is the difference between the CO2 emissions (% of total fuel combustion) of Angola in 2002 and the CO2 emissions (% of total fuel combustion) of Gabon in 2004?
Provide a succinct answer. -1.97. What is the difference between the CO2 emissions (% of total fuel combustion) in Austria in 2002 and the CO2 emissions (% of total fuel combustion) in Bulgaria in 2004?
Make the answer very short. 17.53. What is the difference between the CO2 emissions (% of total fuel combustion) of Austria in 2002 and the CO2 emissions (% of total fuel combustion) of Gabon in 2004?
Offer a very short reply. 6.46. What is the difference between the CO2 emissions (% of total fuel combustion) in Bulgaria in 2002 and the CO2 emissions (% of total fuel combustion) in Gabon in 2004?
Your answer should be very brief. -12.21. What is the difference between the CO2 emissions (% of total fuel combustion) in Angola in 2003 and the CO2 emissions (% of total fuel combustion) in Austria in 2004?
Provide a short and direct response. 3.37. What is the difference between the CO2 emissions (% of total fuel combustion) in Angola in 2003 and the CO2 emissions (% of total fuel combustion) in Bulgaria in 2004?
Your response must be concise. 20.7. What is the difference between the CO2 emissions (% of total fuel combustion) of Angola in 2003 and the CO2 emissions (% of total fuel combustion) of Gabon in 2004?
Offer a terse response. 9.63. What is the difference between the CO2 emissions (% of total fuel combustion) of Austria in 2003 and the CO2 emissions (% of total fuel combustion) of Bulgaria in 2004?
Make the answer very short. 17.38. What is the difference between the CO2 emissions (% of total fuel combustion) of Austria in 2003 and the CO2 emissions (% of total fuel combustion) of Gabon in 2004?
Your answer should be very brief. 6.31. What is the difference between the CO2 emissions (% of total fuel combustion) of Bulgaria in 2003 and the CO2 emissions (% of total fuel combustion) of Gabon in 2004?
Offer a terse response. -12.23. What is the average CO2 emissions (% of total fuel combustion) in Angola per year?
Offer a very short reply. 26.15. What is the average CO2 emissions (% of total fuel combustion) in Austria per year?
Ensure brevity in your answer.  30.05. What is the average CO2 emissions (% of total fuel combustion) in Bulgaria per year?
Your answer should be compact. 12.43. What is the average CO2 emissions (% of total fuel combustion) of Gabon per year?
Offer a very short reply. 24.97. In the year 1997, what is the difference between the CO2 emissions (% of total fuel combustion) in Angola and CO2 emissions (% of total fuel combustion) in Austria?
Keep it short and to the point. -2.02. In the year 1997, what is the difference between the CO2 emissions (% of total fuel combustion) in Angola and CO2 emissions (% of total fuel combustion) in Bulgaria?
Make the answer very short. 15.51. In the year 1997, what is the difference between the CO2 emissions (% of total fuel combustion) of Angola and CO2 emissions (% of total fuel combustion) of Gabon?
Your answer should be compact. -1.04. In the year 1997, what is the difference between the CO2 emissions (% of total fuel combustion) of Austria and CO2 emissions (% of total fuel combustion) of Bulgaria?
Keep it short and to the point. 17.53. In the year 1997, what is the difference between the CO2 emissions (% of total fuel combustion) in Austria and CO2 emissions (% of total fuel combustion) in Gabon?
Keep it short and to the point. 0.98. In the year 1997, what is the difference between the CO2 emissions (% of total fuel combustion) of Bulgaria and CO2 emissions (% of total fuel combustion) of Gabon?
Ensure brevity in your answer.  -16.55. In the year 1998, what is the difference between the CO2 emissions (% of total fuel combustion) in Angola and CO2 emissions (% of total fuel combustion) in Austria?
Your response must be concise. -8.38. In the year 1998, what is the difference between the CO2 emissions (% of total fuel combustion) in Angola and CO2 emissions (% of total fuel combustion) in Bulgaria?
Provide a short and direct response. 9.55. In the year 1998, what is the difference between the CO2 emissions (% of total fuel combustion) in Angola and CO2 emissions (% of total fuel combustion) in Gabon?
Keep it short and to the point. -4. In the year 1998, what is the difference between the CO2 emissions (% of total fuel combustion) of Austria and CO2 emissions (% of total fuel combustion) of Bulgaria?
Provide a short and direct response. 17.93. In the year 1998, what is the difference between the CO2 emissions (% of total fuel combustion) in Austria and CO2 emissions (% of total fuel combustion) in Gabon?
Your answer should be compact. 4.38. In the year 1998, what is the difference between the CO2 emissions (% of total fuel combustion) in Bulgaria and CO2 emissions (% of total fuel combustion) in Gabon?
Provide a succinct answer. -13.55. In the year 1999, what is the difference between the CO2 emissions (% of total fuel combustion) in Angola and CO2 emissions (% of total fuel combustion) in Austria?
Keep it short and to the point. -5.51. In the year 1999, what is the difference between the CO2 emissions (% of total fuel combustion) of Angola and CO2 emissions (% of total fuel combustion) of Bulgaria?
Offer a terse response. 10.35. In the year 1999, what is the difference between the CO2 emissions (% of total fuel combustion) of Angola and CO2 emissions (% of total fuel combustion) of Gabon?
Your answer should be compact. -1.48. In the year 1999, what is the difference between the CO2 emissions (% of total fuel combustion) of Austria and CO2 emissions (% of total fuel combustion) of Bulgaria?
Make the answer very short. 15.87. In the year 1999, what is the difference between the CO2 emissions (% of total fuel combustion) in Austria and CO2 emissions (% of total fuel combustion) in Gabon?
Your answer should be compact. 4.04. In the year 1999, what is the difference between the CO2 emissions (% of total fuel combustion) in Bulgaria and CO2 emissions (% of total fuel combustion) in Gabon?
Keep it short and to the point. -11.83. In the year 2000, what is the difference between the CO2 emissions (% of total fuel combustion) of Angola and CO2 emissions (% of total fuel combustion) of Austria?
Your response must be concise. -9.06. In the year 2000, what is the difference between the CO2 emissions (% of total fuel combustion) of Angola and CO2 emissions (% of total fuel combustion) of Bulgaria?
Your answer should be very brief. 8.17. In the year 2000, what is the difference between the CO2 emissions (% of total fuel combustion) in Angola and CO2 emissions (% of total fuel combustion) in Gabon?
Provide a succinct answer. -0.9. In the year 2000, what is the difference between the CO2 emissions (% of total fuel combustion) of Austria and CO2 emissions (% of total fuel combustion) of Bulgaria?
Your answer should be very brief. 17.22. In the year 2000, what is the difference between the CO2 emissions (% of total fuel combustion) in Austria and CO2 emissions (% of total fuel combustion) in Gabon?
Your answer should be very brief. 8.15. In the year 2000, what is the difference between the CO2 emissions (% of total fuel combustion) in Bulgaria and CO2 emissions (% of total fuel combustion) in Gabon?
Provide a succinct answer. -9.07. In the year 2001, what is the difference between the CO2 emissions (% of total fuel combustion) of Angola and CO2 emissions (% of total fuel combustion) of Austria?
Make the answer very short. -8.88. In the year 2001, what is the difference between the CO2 emissions (% of total fuel combustion) in Angola and CO2 emissions (% of total fuel combustion) in Bulgaria?
Offer a terse response. 9.05. In the year 2001, what is the difference between the CO2 emissions (% of total fuel combustion) in Angola and CO2 emissions (% of total fuel combustion) in Gabon?
Your response must be concise. -3.13. In the year 2001, what is the difference between the CO2 emissions (% of total fuel combustion) of Austria and CO2 emissions (% of total fuel combustion) of Bulgaria?
Keep it short and to the point. 17.93. In the year 2001, what is the difference between the CO2 emissions (% of total fuel combustion) of Austria and CO2 emissions (% of total fuel combustion) of Gabon?
Provide a short and direct response. 5.75. In the year 2001, what is the difference between the CO2 emissions (% of total fuel combustion) of Bulgaria and CO2 emissions (% of total fuel combustion) of Gabon?
Offer a very short reply. -12.17. In the year 2002, what is the difference between the CO2 emissions (% of total fuel combustion) of Angola and CO2 emissions (% of total fuel combustion) of Austria?
Your answer should be very brief. -8.43. In the year 2002, what is the difference between the CO2 emissions (% of total fuel combustion) of Angola and CO2 emissions (% of total fuel combustion) of Bulgaria?
Provide a succinct answer. 10.24. In the year 2002, what is the difference between the CO2 emissions (% of total fuel combustion) of Angola and CO2 emissions (% of total fuel combustion) of Gabon?
Give a very brief answer. -4.36. In the year 2002, what is the difference between the CO2 emissions (% of total fuel combustion) of Austria and CO2 emissions (% of total fuel combustion) of Bulgaria?
Make the answer very short. 18.67. In the year 2002, what is the difference between the CO2 emissions (% of total fuel combustion) in Austria and CO2 emissions (% of total fuel combustion) in Gabon?
Give a very brief answer. 4.07. In the year 2002, what is the difference between the CO2 emissions (% of total fuel combustion) in Bulgaria and CO2 emissions (% of total fuel combustion) in Gabon?
Offer a terse response. -14.6. In the year 2003, what is the difference between the CO2 emissions (% of total fuel combustion) in Angola and CO2 emissions (% of total fuel combustion) in Austria?
Provide a succinct answer. 3.32. In the year 2003, what is the difference between the CO2 emissions (% of total fuel combustion) in Angola and CO2 emissions (% of total fuel combustion) in Bulgaria?
Provide a short and direct response. 21.86. In the year 2003, what is the difference between the CO2 emissions (% of total fuel combustion) in Angola and CO2 emissions (% of total fuel combustion) in Gabon?
Ensure brevity in your answer.  10.32. In the year 2003, what is the difference between the CO2 emissions (% of total fuel combustion) of Austria and CO2 emissions (% of total fuel combustion) of Bulgaria?
Ensure brevity in your answer.  18.54. In the year 2003, what is the difference between the CO2 emissions (% of total fuel combustion) in Austria and CO2 emissions (% of total fuel combustion) in Gabon?
Give a very brief answer. 7. In the year 2003, what is the difference between the CO2 emissions (% of total fuel combustion) in Bulgaria and CO2 emissions (% of total fuel combustion) in Gabon?
Offer a terse response. -11.54. In the year 2004, what is the difference between the CO2 emissions (% of total fuel combustion) in Angola and CO2 emissions (% of total fuel combustion) in Austria?
Provide a short and direct response. 7.74. In the year 2004, what is the difference between the CO2 emissions (% of total fuel combustion) of Angola and CO2 emissions (% of total fuel combustion) of Bulgaria?
Make the answer very short. 25.07. In the year 2004, what is the difference between the CO2 emissions (% of total fuel combustion) in Angola and CO2 emissions (% of total fuel combustion) in Gabon?
Your answer should be very brief. 14. In the year 2004, what is the difference between the CO2 emissions (% of total fuel combustion) in Austria and CO2 emissions (% of total fuel combustion) in Bulgaria?
Offer a terse response. 17.33. In the year 2004, what is the difference between the CO2 emissions (% of total fuel combustion) in Austria and CO2 emissions (% of total fuel combustion) in Gabon?
Make the answer very short. 6.26. In the year 2004, what is the difference between the CO2 emissions (% of total fuel combustion) in Bulgaria and CO2 emissions (% of total fuel combustion) in Gabon?
Make the answer very short. -11.07. What is the ratio of the CO2 emissions (% of total fuel combustion) of Angola in 1997 to that in 1998?
Keep it short and to the point. 1.16. What is the ratio of the CO2 emissions (% of total fuel combustion) of Austria in 1997 to that in 1998?
Make the answer very short. 0.89. What is the ratio of the CO2 emissions (% of total fuel combustion) in Bulgaria in 1997 to that in 1998?
Your answer should be compact. 0.75. What is the ratio of the CO2 emissions (% of total fuel combustion) in Gabon in 1997 to that in 1998?
Give a very brief answer. 1.01. What is the ratio of the CO2 emissions (% of total fuel combustion) in Angola in 1997 to that in 1999?
Keep it short and to the point. 1.02. What is the ratio of the CO2 emissions (% of total fuel combustion) of Austria in 1997 to that in 1999?
Your response must be concise. 0.89. What is the ratio of the CO2 emissions (% of total fuel combustion) of Bulgaria in 1997 to that in 1999?
Make the answer very short. 0.64. What is the ratio of the CO2 emissions (% of total fuel combustion) in Angola in 1997 to that in 2000?
Make the answer very short. 1.14. What is the ratio of the CO2 emissions (% of total fuel combustion) in Austria in 1997 to that in 2000?
Offer a terse response. 0.86. What is the ratio of the CO2 emissions (% of total fuel combustion) in Bulgaria in 1997 to that in 2000?
Give a very brief answer. 0.65. What is the ratio of the CO2 emissions (% of total fuel combustion) in Gabon in 1997 to that in 2000?
Provide a short and direct response. 1.14. What is the ratio of the CO2 emissions (% of total fuel combustion) of Angola in 1997 to that in 2001?
Offer a very short reply. 1.11. What is the ratio of the CO2 emissions (% of total fuel combustion) in Austria in 1997 to that in 2001?
Offer a very short reply. 0.85. What is the ratio of the CO2 emissions (% of total fuel combustion) of Bulgaria in 1997 to that in 2001?
Provide a short and direct response. 0.67. What is the ratio of the CO2 emissions (% of total fuel combustion) of Gabon in 1997 to that in 2001?
Provide a succinct answer. 1.01. What is the ratio of the CO2 emissions (% of total fuel combustion) in Austria in 1997 to that in 2002?
Your answer should be very brief. 0.8. What is the ratio of the CO2 emissions (% of total fuel combustion) in Bulgaria in 1997 to that in 2002?
Keep it short and to the point. 0.61. What is the ratio of the CO2 emissions (% of total fuel combustion) of Gabon in 1997 to that in 2002?
Your response must be concise. 0.88. What is the ratio of the CO2 emissions (% of total fuel combustion) in Angola in 1997 to that in 2003?
Make the answer very short. 0.67. What is the ratio of the CO2 emissions (% of total fuel combustion) in Austria in 1997 to that in 2003?
Provide a succinct answer. 0.8. What is the ratio of the CO2 emissions (% of total fuel combustion) of Bulgaria in 1997 to that in 2003?
Keep it short and to the point. 0.61. What is the ratio of the CO2 emissions (% of total fuel combustion) of Gabon in 1997 to that in 2003?
Give a very brief answer. 0.99. What is the ratio of the CO2 emissions (% of total fuel combustion) of Angola in 1997 to that in 2004?
Offer a very short reply. 0.6. What is the ratio of the CO2 emissions (% of total fuel combustion) in Austria in 1997 to that in 2004?
Offer a terse response. 0.8. What is the ratio of the CO2 emissions (% of total fuel combustion) of Bulgaria in 1997 to that in 2004?
Provide a short and direct response. 0.56. What is the ratio of the CO2 emissions (% of total fuel combustion) in Gabon in 1997 to that in 2004?
Provide a succinct answer. 0.96. What is the ratio of the CO2 emissions (% of total fuel combustion) in Angola in 1998 to that in 1999?
Your response must be concise. 0.88. What is the ratio of the CO2 emissions (% of total fuel combustion) in Bulgaria in 1998 to that in 1999?
Your response must be concise. 0.84. What is the ratio of the CO2 emissions (% of total fuel combustion) of Gabon in 1998 to that in 1999?
Your answer should be compact. 0.99. What is the ratio of the CO2 emissions (% of total fuel combustion) of Angola in 1998 to that in 2000?
Offer a terse response. 0.98. What is the ratio of the CO2 emissions (% of total fuel combustion) in Austria in 1998 to that in 2000?
Provide a short and direct response. 0.97. What is the ratio of the CO2 emissions (% of total fuel combustion) of Bulgaria in 1998 to that in 2000?
Your answer should be very brief. 0.87. What is the ratio of the CO2 emissions (% of total fuel combustion) in Gabon in 1998 to that in 2000?
Provide a succinct answer. 1.13. What is the ratio of the CO2 emissions (% of total fuel combustion) of Angola in 1998 to that in 2001?
Make the answer very short. 0.96. What is the ratio of the CO2 emissions (% of total fuel combustion) of Austria in 1998 to that in 2001?
Provide a succinct answer. 0.96. What is the ratio of the CO2 emissions (% of total fuel combustion) of Bulgaria in 1998 to that in 2001?
Your answer should be very brief. 0.89. What is the ratio of the CO2 emissions (% of total fuel combustion) of Angola in 1998 to that in 2002?
Your answer should be very brief. 0.86. What is the ratio of the CO2 emissions (% of total fuel combustion) of Austria in 1998 to that in 2002?
Keep it short and to the point. 0.89. What is the ratio of the CO2 emissions (% of total fuel combustion) in Bulgaria in 1998 to that in 2002?
Ensure brevity in your answer.  0.8. What is the ratio of the CO2 emissions (% of total fuel combustion) in Gabon in 1998 to that in 2002?
Ensure brevity in your answer.  0.87. What is the ratio of the CO2 emissions (% of total fuel combustion) in Angola in 1998 to that in 2003?
Provide a short and direct response. 0.58. What is the ratio of the CO2 emissions (% of total fuel combustion) in Austria in 1998 to that in 2003?
Make the answer very short. 0.9. What is the ratio of the CO2 emissions (% of total fuel combustion) in Bulgaria in 1998 to that in 2003?
Provide a succinct answer. 0.81. What is the ratio of the CO2 emissions (% of total fuel combustion) of Gabon in 1998 to that in 2003?
Provide a short and direct response. 0.97. What is the ratio of the CO2 emissions (% of total fuel combustion) in Angola in 1998 to that in 2004?
Your answer should be compact. 0.52. What is the ratio of the CO2 emissions (% of total fuel combustion) of Austria in 1998 to that in 2004?
Your response must be concise. 0.9. What is the ratio of the CO2 emissions (% of total fuel combustion) in Bulgaria in 1998 to that in 2004?
Your answer should be compact. 0.74. What is the ratio of the CO2 emissions (% of total fuel combustion) in Gabon in 1998 to that in 2004?
Offer a terse response. 0.95. What is the ratio of the CO2 emissions (% of total fuel combustion) in Angola in 1999 to that in 2000?
Keep it short and to the point. 1.12. What is the ratio of the CO2 emissions (% of total fuel combustion) in Austria in 1999 to that in 2000?
Give a very brief answer. 0.96. What is the ratio of the CO2 emissions (% of total fuel combustion) of Bulgaria in 1999 to that in 2000?
Offer a terse response. 1.02. What is the ratio of the CO2 emissions (% of total fuel combustion) in Gabon in 1999 to that in 2000?
Give a very brief answer. 1.14. What is the ratio of the CO2 emissions (% of total fuel combustion) in Angola in 1999 to that in 2001?
Offer a terse response. 1.09. What is the ratio of the CO2 emissions (% of total fuel combustion) of Austria in 1999 to that in 2001?
Give a very brief answer. 0.95. What is the ratio of the CO2 emissions (% of total fuel combustion) in Bulgaria in 1999 to that in 2001?
Make the answer very short. 1.06. What is the ratio of the CO2 emissions (% of total fuel combustion) in Gabon in 1999 to that in 2001?
Make the answer very short. 1.01. What is the ratio of the CO2 emissions (% of total fuel combustion) in Angola in 1999 to that in 2002?
Ensure brevity in your answer.  0.98. What is the ratio of the CO2 emissions (% of total fuel combustion) of Austria in 1999 to that in 2002?
Give a very brief answer. 0.89. What is the ratio of the CO2 emissions (% of total fuel combustion) of Bulgaria in 1999 to that in 2002?
Offer a terse response. 0.95. What is the ratio of the CO2 emissions (% of total fuel combustion) in Gabon in 1999 to that in 2002?
Keep it short and to the point. 0.88. What is the ratio of the CO2 emissions (% of total fuel combustion) of Angola in 1999 to that in 2003?
Offer a terse response. 0.66. What is the ratio of the CO2 emissions (% of total fuel combustion) of Austria in 1999 to that in 2003?
Offer a very short reply. 0.9. What is the ratio of the CO2 emissions (% of total fuel combustion) in Bulgaria in 1999 to that in 2003?
Keep it short and to the point. 0.95. What is the ratio of the CO2 emissions (% of total fuel combustion) in Gabon in 1999 to that in 2003?
Give a very brief answer. 0.99. What is the ratio of the CO2 emissions (% of total fuel combustion) in Angola in 1999 to that in 2004?
Ensure brevity in your answer.  0.59. What is the ratio of the CO2 emissions (% of total fuel combustion) of Austria in 1999 to that in 2004?
Provide a short and direct response. 0.9. What is the ratio of the CO2 emissions (% of total fuel combustion) in Bulgaria in 1999 to that in 2004?
Your response must be concise. 0.88. What is the ratio of the CO2 emissions (% of total fuel combustion) of Gabon in 1999 to that in 2004?
Provide a succinct answer. 0.96. What is the ratio of the CO2 emissions (% of total fuel combustion) in Angola in 2000 to that in 2001?
Offer a very short reply. 0.98. What is the ratio of the CO2 emissions (% of total fuel combustion) in Austria in 2000 to that in 2001?
Provide a short and direct response. 0.99. What is the ratio of the CO2 emissions (% of total fuel combustion) in Bulgaria in 2000 to that in 2001?
Offer a very short reply. 1.03. What is the ratio of the CO2 emissions (% of total fuel combustion) of Gabon in 2000 to that in 2001?
Give a very brief answer. 0.89. What is the ratio of the CO2 emissions (% of total fuel combustion) of Angola in 2000 to that in 2002?
Keep it short and to the point. 0.87. What is the ratio of the CO2 emissions (% of total fuel combustion) in Austria in 2000 to that in 2002?
Your answer should be compact. 0.93. What is the ratio of the CO2 emissions (% of total fuel combustion) in Bulgaria in 2000 to that in 2002?
Your answer should be very brief. 0.93. What is the ratio of the CO2 emissions (% of total fuel combustion) in Gabon in 2000 to that in 2002?
Your answer should be very brief. 0.77. What is the ratio of the CO2 emissions (% of total fuel combustion) in Angola in 2000 to that in 2003?
Provide a short and direct response. 0.59. What is the ratio of the CO2 emissions (% of total fuel combustion) of Austria in 2000 to that in 2003?
Give a very brief answer. 0.93. What is the ratio of the CO2 emissions (% of total fuel combustion) of Bulgaria in 2000 to that in 2003?
Make the answer very short. 0.93. What is the ratio of the CO2 emissions (% of total fuel combustion) of Gabon in 2000 to that in 2003?
Your response must be concise. 0.86. What is the ratio of the CO2 emissions (% of total fuel combustion) of Angola in 2000 to that in 2004?
Your response must be concise. 0.52. What is the ratio of the CO2 emissions (% of total fuel combustion) of Austria in 2000 to that in 2004?
Your response must be concise. 0.93. What is the ratio of the CO2 emissions (% of total fuel combustion) in Bulgaria in 2000 to that in 2004?
Offer a terse response. 0.86. What is the ratio of the CO2 emissions (% of total fuel combustion) in Gabon in 2000 to that in 2004?
Give a very brief answer. 0.84. What is the ratio of the CO2 emissions (% of total fuel combustion) of Angola in 2001 to that in 2002?
Give a very brief answer. 0.89. What is the ratio of the CO2 emissions (% of total fuel combustion) of Austria in 2001 to that in 2002?
Offer a terse response. 0.94. What is the ratio of the CO2 emissions (% of total fuel combustion) of Bulgaria in 2001 to that in 2002?
Provide a short and direct response. 0.9. What is the ratio of the CO2 emissions (% of total fuel combustion) in Gabon in 2001 to that in 2002?
Keep it short and to the point. 0.87. What is the ratio of the CO2 emissions (% of total fuel combustion) of Angola in 2001 to that in 2003?
Offer a very short reply. 0.6. What is the ratio of the CO2 emissions (% of total fuel combustion) of Austria in 2001 to that in 2003?
Keep it short and to the point. 0.94. What is the ratio of the CO2 emissions (% of total fuel combustion) of Bulgaria in 2001 to that in 2003?
Offer a very short reply. 0.9. What is the ratio of the CO2 emissions (% of total fuel combustion) of Gabon in 2001 to that in 2003?
Your answer should be very brief. 0.97. What is the ratio of the CO2 emissions (% of total fuel combustion) of Angola in 2001 to that in 2004?
Your response must be concise. 0.54. What is the ratio of the CO2 emissions (% of total fuel combustion) in Austria in 2001 to that in 2004?
Your answer should be very brief. 0.94. What is the ratio of the CO2 emissions (% of total fuel combustion) of Bulgaria in 2001 to that in 2004?
Give a very brief answer. 0.83. What is the ratio of the CO2 emissions (% of total fuel combustion) of Gabon in 2001 to that in 2004?
Provide a succinct answer. 0.95. What is the ratio of the CO2 emissions (% of total fuel combustion) in Angola in 2002 to that in 2003?
Offer a terse response. 0.67. What is the ratio of the CO2 emissions (% of total fuel combustion) in Austria in 2002 to that in 2003?
Offer a very short reply. 1. What is the ratio of the CO2 emissions (% of total fuel combustion) in Gabon in 2002 to that in 2003?
Keep it short and to the point. 1.12. What is the ratio of the CO2 emissions (% of total fuel combustion) in Angola in 2002 to that in 2004?
Offer a terse response. 0.6. What is the ratio of the CO2 emissions (% of total fuel combustion) of Bulgaria in 2002 to that in 2004?
Provide a succinct answer. 0.92. What is the ratio of the CO2 emissions (% of total fuel combustion) in Gabon in 2002 to that in 2004?
Offer a terse response. 1.09. What is the ratio of the CO2 emissions (% of total fuel combustion) in Angola in 2003 to that in 2004?
Make the answer very short. 0.89. What is the ratio of the CO2 emissions (% of total fuel combustion) of Bulgaria in 2003 to that in 2004?
Provide a short and direct response. 0.92. What is the ratio of the CO2 emissions (% of total fuel combustion) of Gabon in 2003 to that in 2004?
Provide a succinct answer. 0.97. What is the difference between the highest and the second highest CO2 emissions (% of total fuel combustion) in Angola?
Ensure brevity in your answer.  4.37. What is the difference between the highest and the second highest CO2 emissions (% of total fuel combustion) of Austria?
Offer a very short reply. 0.15. What is the difference between the highest and the second highest CO2 emissions (% of total fuel combustion) of Bulgaria?
Provide a succinct answer. 1.14. What is the difference between the highest and the second highest CO2 emissions (% of total fuel combustion) in Gabon?
Provide a short and direct response. 2.39. What is the difference between the highest and the lowest CO2 emissions (% of total fuel combustion) in Angola?
Ensure brevity in your answer.  19.33. What is the difference between the highest and the lowest CO2 emissions (% of total fuel combustion) of Austria?
Ensure brevity in your answer.  6.52. What is the difference between the highest and the lowest CO2 emissions (% of total fuel combustion) of Bulgaria?
Give a very brief answer. 6.51. What is the difference between the highest and the lowest CO2 emissions (% of total fuel combustion) of Gabon?
Offer a terse response. 6.49. 